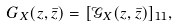<formula> <loc_0><loc_0><loc_500><loc_500>G _ { X } ( z , \bar { z } ) = [ \mathcal { G } _ { X } ( z , \bar { z } ) ] _ { 1 1 } ,</formula> 